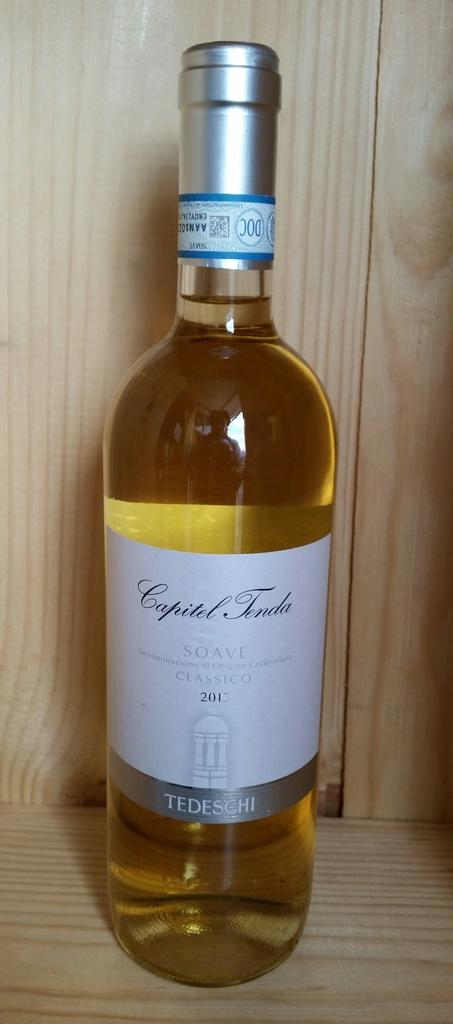Provide a one-sentence caption for the provided image. A full bottle of white wine from  2013. 